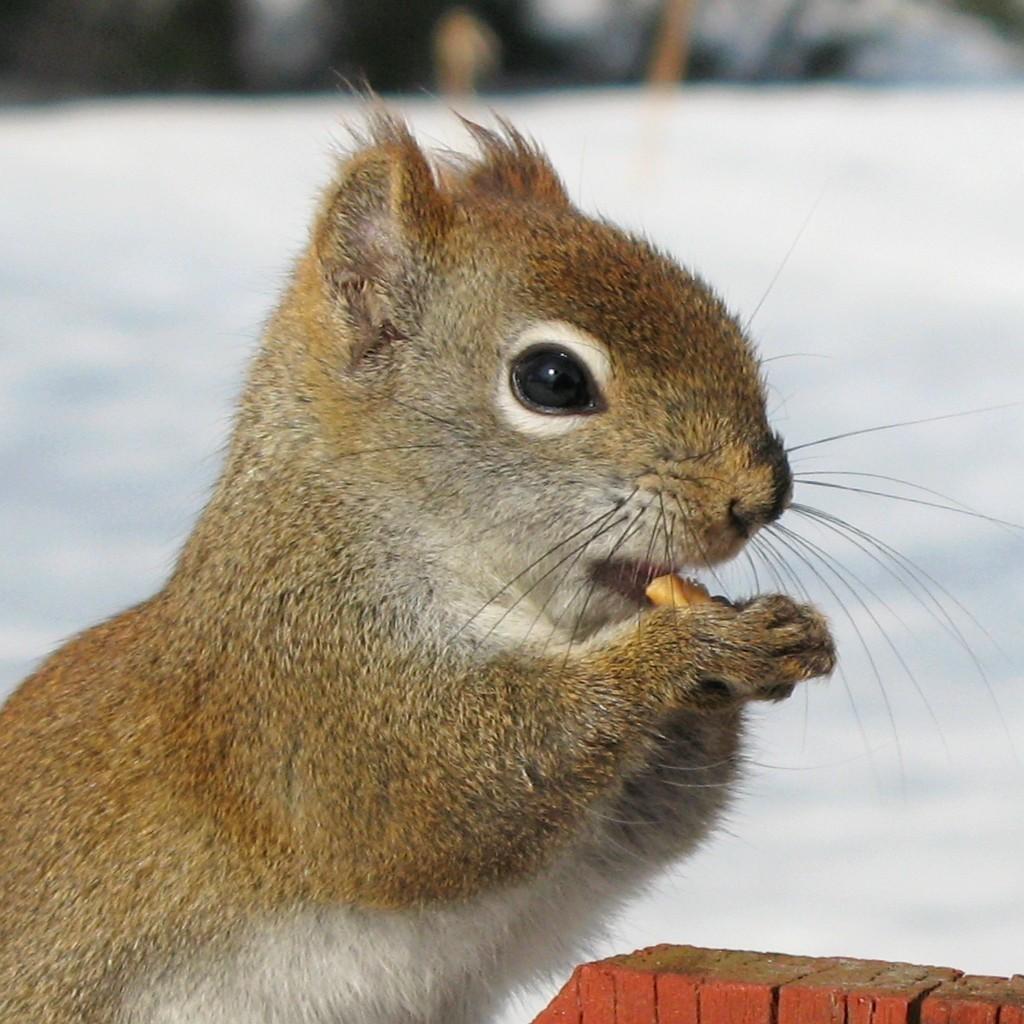Please provide a concise description of this image. There is a cute brown squirrel eating some food item. 